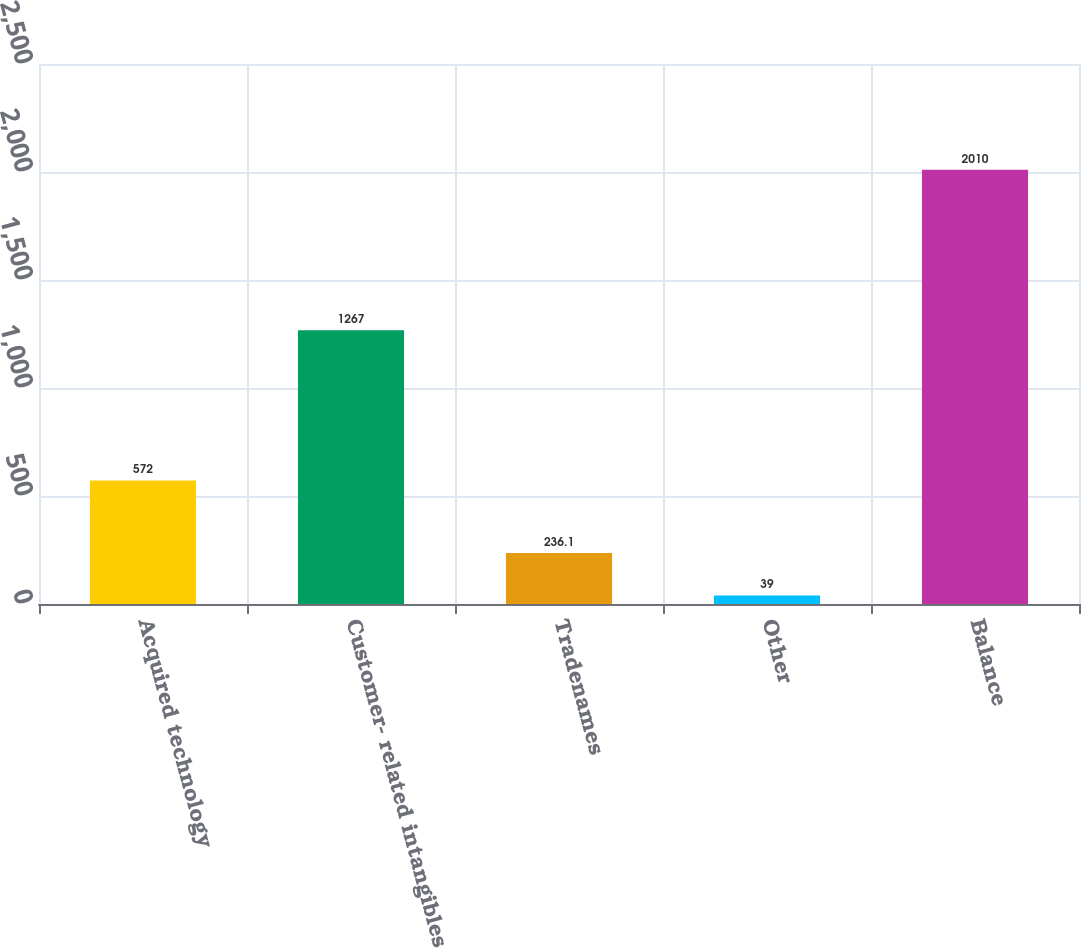<chart> <loc_0><loc_0><loc_500><loc_500><bar_chart><fcel>Acquired technology<fcel>Customer- related intangibles<fcel>Tradenames<fcel>Other<fcel>Balance<nl><fcel>572<fcel>1267<fcel>236.1<fcel>39<fcel>2010<nl></chart> 